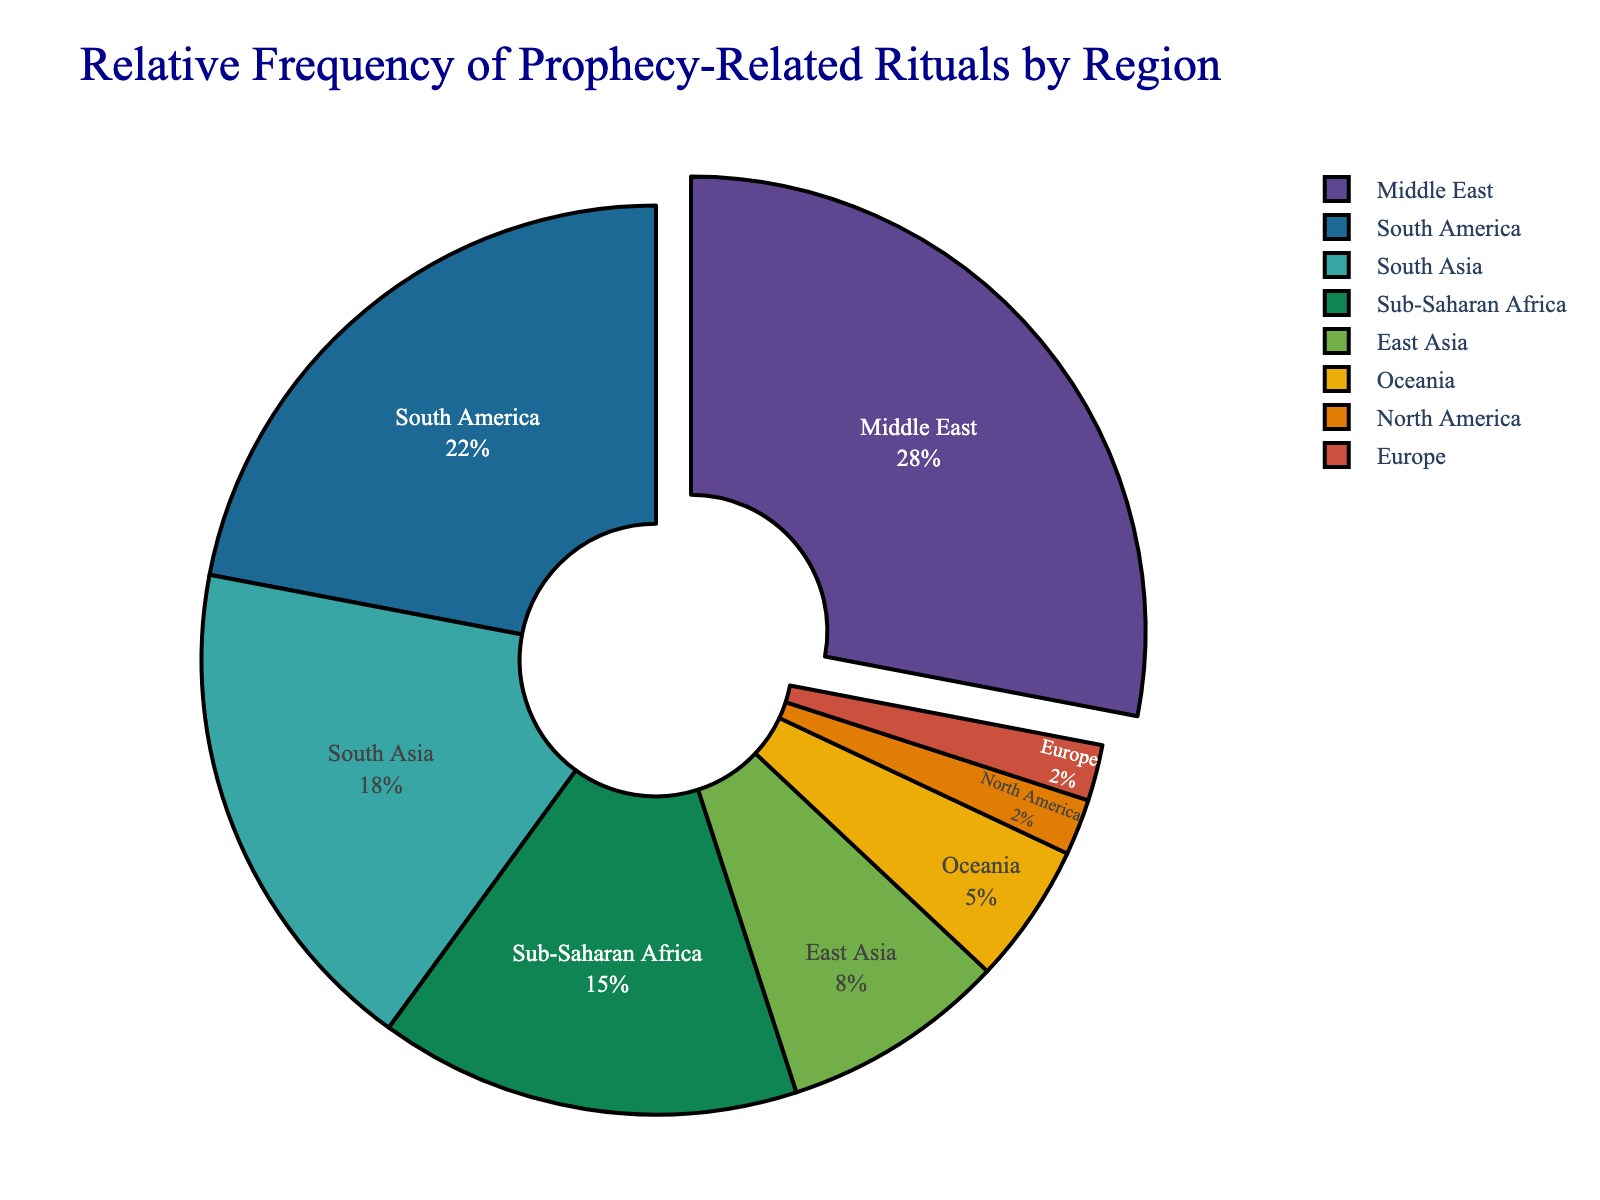What is the region with the highest relative frequency of prophecy-related rituals? The region with the highest relative frequency of prophecy-related rituals stands out due to its larger segment size and the slight "pull" effect enhancing its visibility. By examining the segments, the Middle East has the largest portion.
Answer: Middle East Which region has the second-highest frequency of prophecy-related rituals? By comparing the sizes of the segments, the second-largest segment represents South America.
Answer: South America How does the combined frequency of South Asia and Sub-Saharan Africa compare to the Middle East? Adding the frequencies of South Asia (18) and Sub-Saharan Africa (15) results in 33. The Middle East has a frequency of 28, so the combined frequency is higher.
Answer: Higher List the regions with frequencies less than 10. By inspecting the segments with smaller areas, the regions with frequencies less than 10 are East Asia, Oceania, North America, and Europe.
Answer: East Asia, Oceania, North America, Europe What percentage of the total does the region with the lowest frequency represent? North America and Europe both have the lowest frequency, 2. The total is 100. Representing (2/100)*100% gives 2%.
Answer: 2% How much larger in frequency is East Asia compared to Oceania? East Asia's frequency is 8, and Oceania's frequency is 5. The difference is calculated as 8 - 5 = 3.
Answer: 3 If you combine the frequencies of North America and Europe, do they surpass Oceania? The combined frequency of North America (2) and Europe (2) is 2 + 2 = 4, which is less than Oceania's 5.
Answer: No What is the combined frequency of Middle East, South Asia, and Oceania? Summing up the frequencies: Middle East (28), South Asia (18), and Oceania (5) gives 28 + 18 + 5 = 51.
Answer: 51 Which region's segment appears to be colored in the most saturated color? By visually inspecting the segments, the Middle East's segment is rendered with the most prominent and saturated color as it often corresponds to key data points in plots.
Answer: Middle East What is the sum of the frequencies of regions with more than 15 counts? The regions are Middle East (28) and South America (22). Adding them gives 28 + 22 = 50.
Answer: 50 